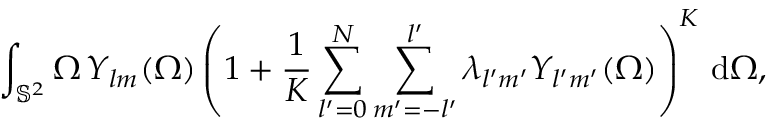<formula> <loc_0><loc_0><loc_500><loc_500>\int _ { \mathbb { S } ^ { 2 } } \Omega \, Y _ { l m } ( \Omega ) \left ( 1 + \frac { 1 } { K } \sum _ { l ^ { \prime } = 0 } ^ { N } \sum _ { m ^ { \prime } = - l ^ { \prime } } ^ { l ^ { \prime } } \lambda _ { l ^ { \prime } m ^ { \prime } } Y _ { l ^ { \prime } m ^ { \prime } } ( \Omega ) \right ) ^ { K } \, d \Omega ,</formula> 